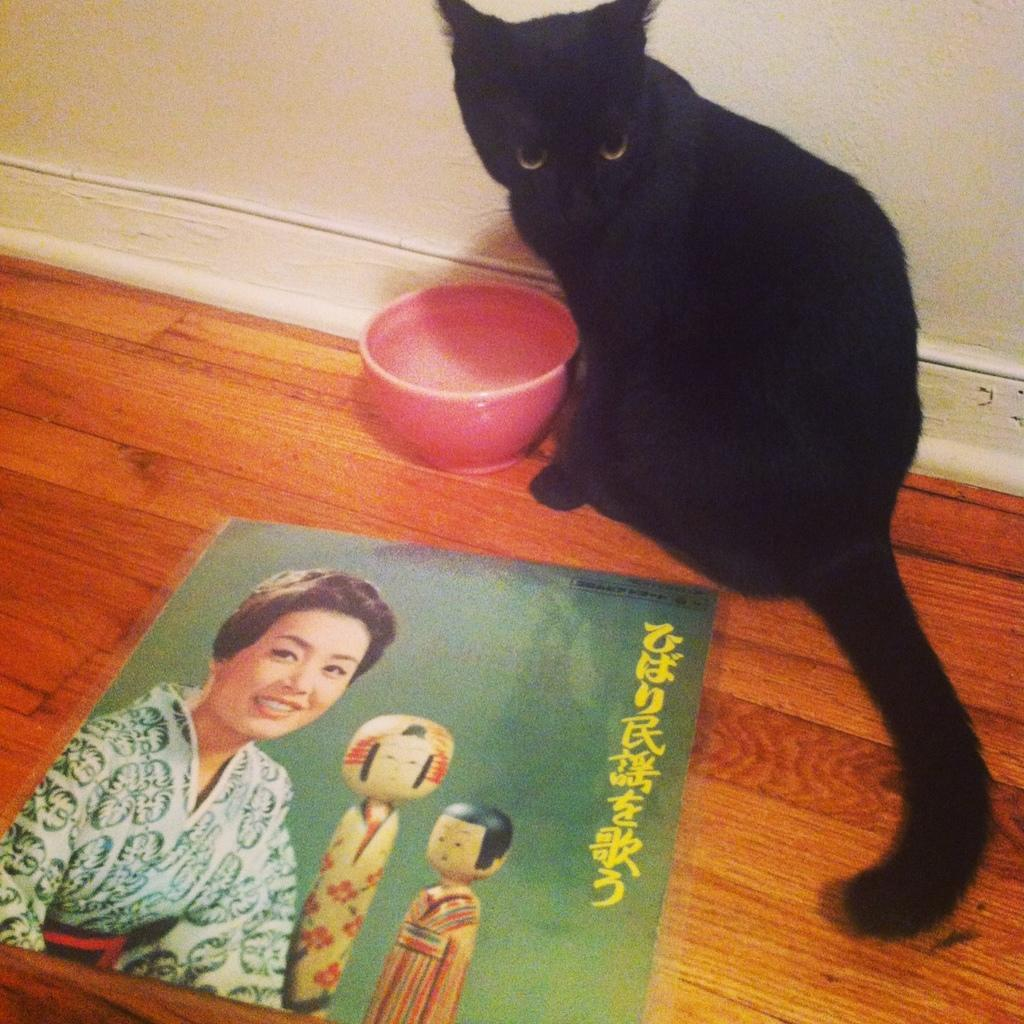What type of animal can be seen in the image? There is a black color cat in the image. What is located on the floor in the image? There is a bowl on the floor in the image. What is depicted on the poster in the image? There is a poster of a woman with two dolls in the image. What can be seen in the background of the image? There is a wall in the background of the image. What type of destruction is caused by the plastic substance in the image? There is no plastic substance or destruction present in the image. What type of plastic is used to create the cat in the image? The cat in the image is a real animal, not made of plastic. 